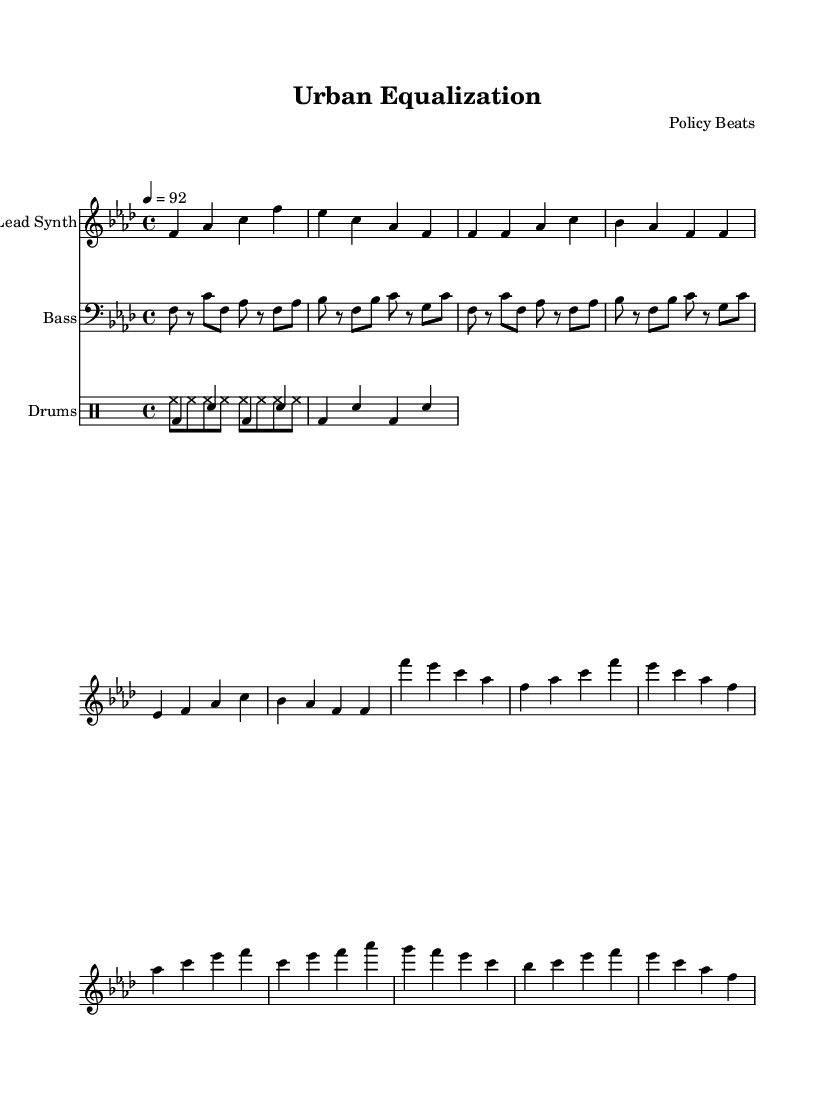What is the key signature of this music? The key signature shows one flat, which corresponds to F major or D minor. In this case, it's indicated in F minor.
Answer: F minor What is the time signature of this music? The time signature, found at the beginning of the score after the key signature, is 4/4, indicating four beats per measure.
Answer: 4/4 What is the tempo set for this piece? The tempo marking, indicated by the number after "tempo," is a quarter note equaling 92 beats per minute.
Answer: 92 How many measures are in the chorus section? To determine the number of measures, count the measures specifically within the chorus section marked in the sheet music. The chorus is made up of four measures.
Answer: 4 What instrument plays the lead synth part? The instrument name is specified on the staff in the score; it clearly states "Lead Synth" as the instrument.
Answer: Lead Synth Identify the rhythmic pattern used for the drums. The drum part is characterized by bass drum and snare rhythms, indicating a basic hip-hop beat by alternating bass and snare hits, creating a groove commonly found in hip-hop music.
Answer: Hip-hop beat What is the primary theme of the lyrics suggested by the composition? While the sheet music does not contain lyrics, the title "Urban Equalization" and the instrumentation choices hint at themes surrounding social equality and urban issues relevant to hip-hop.
Answer: Social equality 